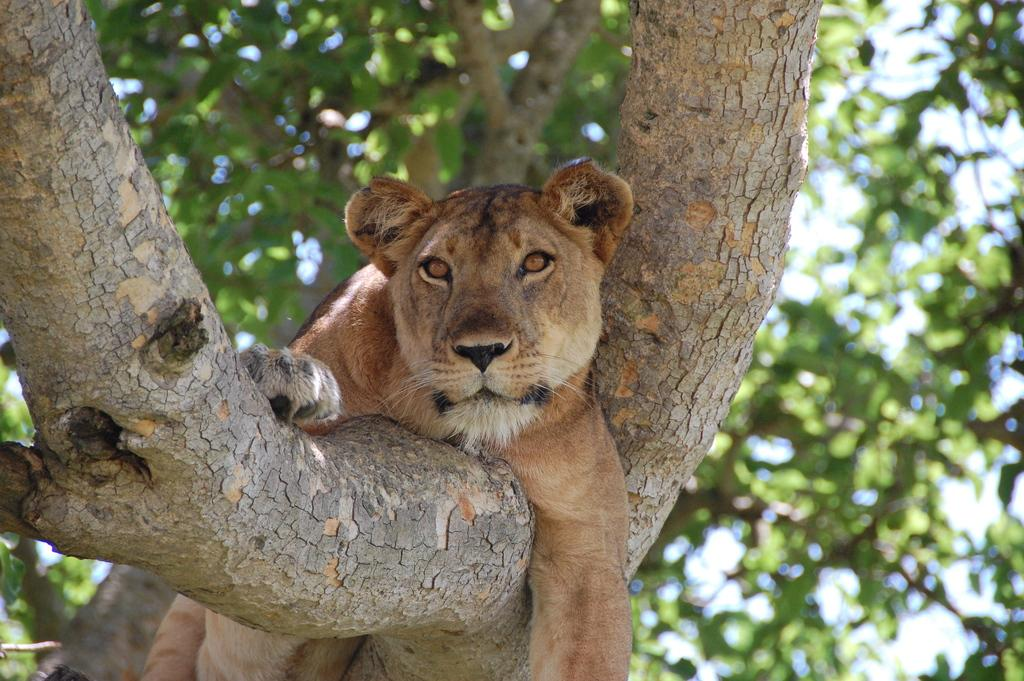What animal is featured in the image? There is a lion in the image. Where is the lion located? The lion is on a branch. What can be seen in the background of the image? There are trees and the sky visible in the background of the image. What type of magic is the lion performing in the image? There is no magic or any indication of the lion performing any magic in the image. 